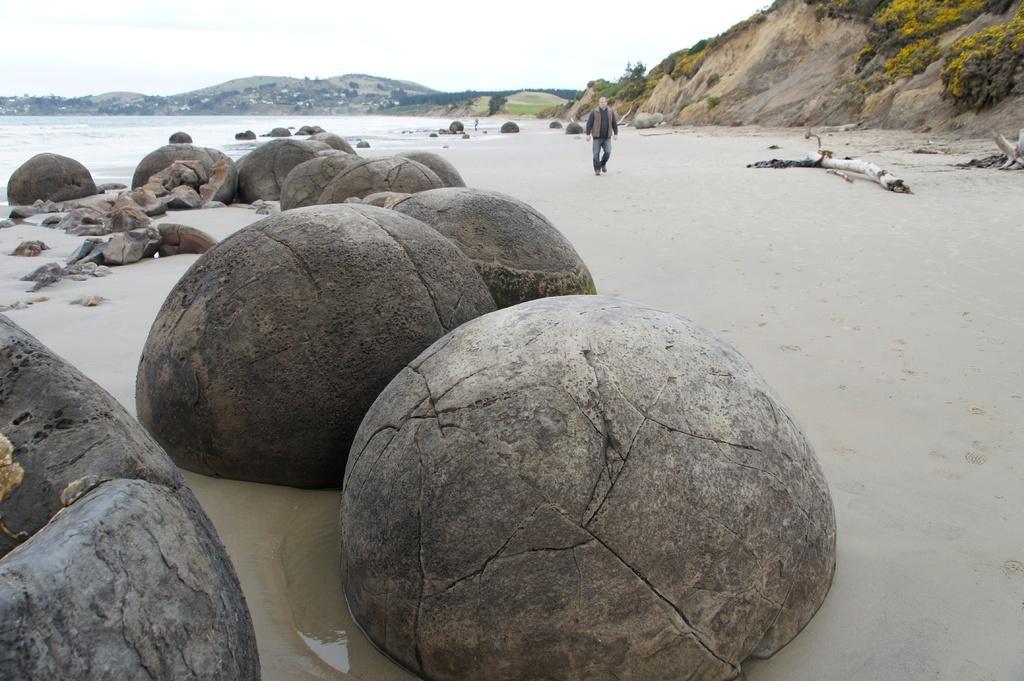Please provide a concise description of this image. In this image I can see few huge rocks which are black and brown in color, the ground, few wooden logs and a person standing. I can see the water and few mountains. In the background I can see the sky. 